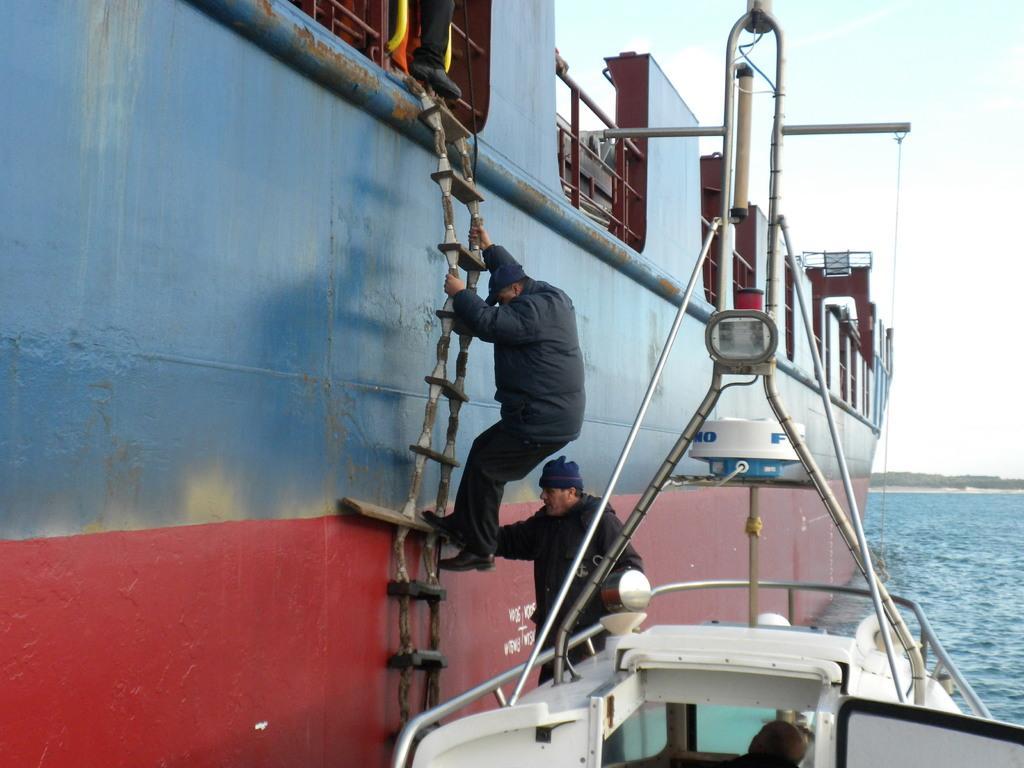Describe this image in one or two sentences. In this image a person wearing a black jacket is climbing the ladder which is onto the ship. He is wearing a cap and shoes. Behind him there is a person standing on the boat. Bottom of image there is a person in the boat. Right side there is water. There are few trees on the land. Top of image there is sky. 